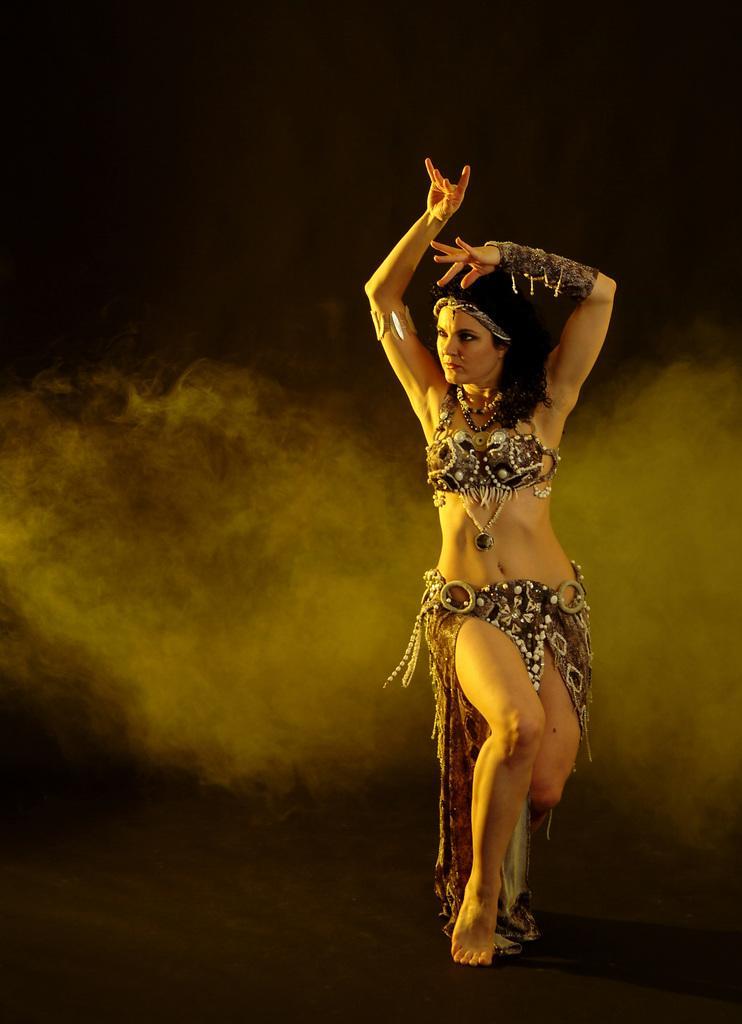Can you describe this image briefly? In this image we can see a woman is dancing on the floor. There is a dark background and we can see smoke. 